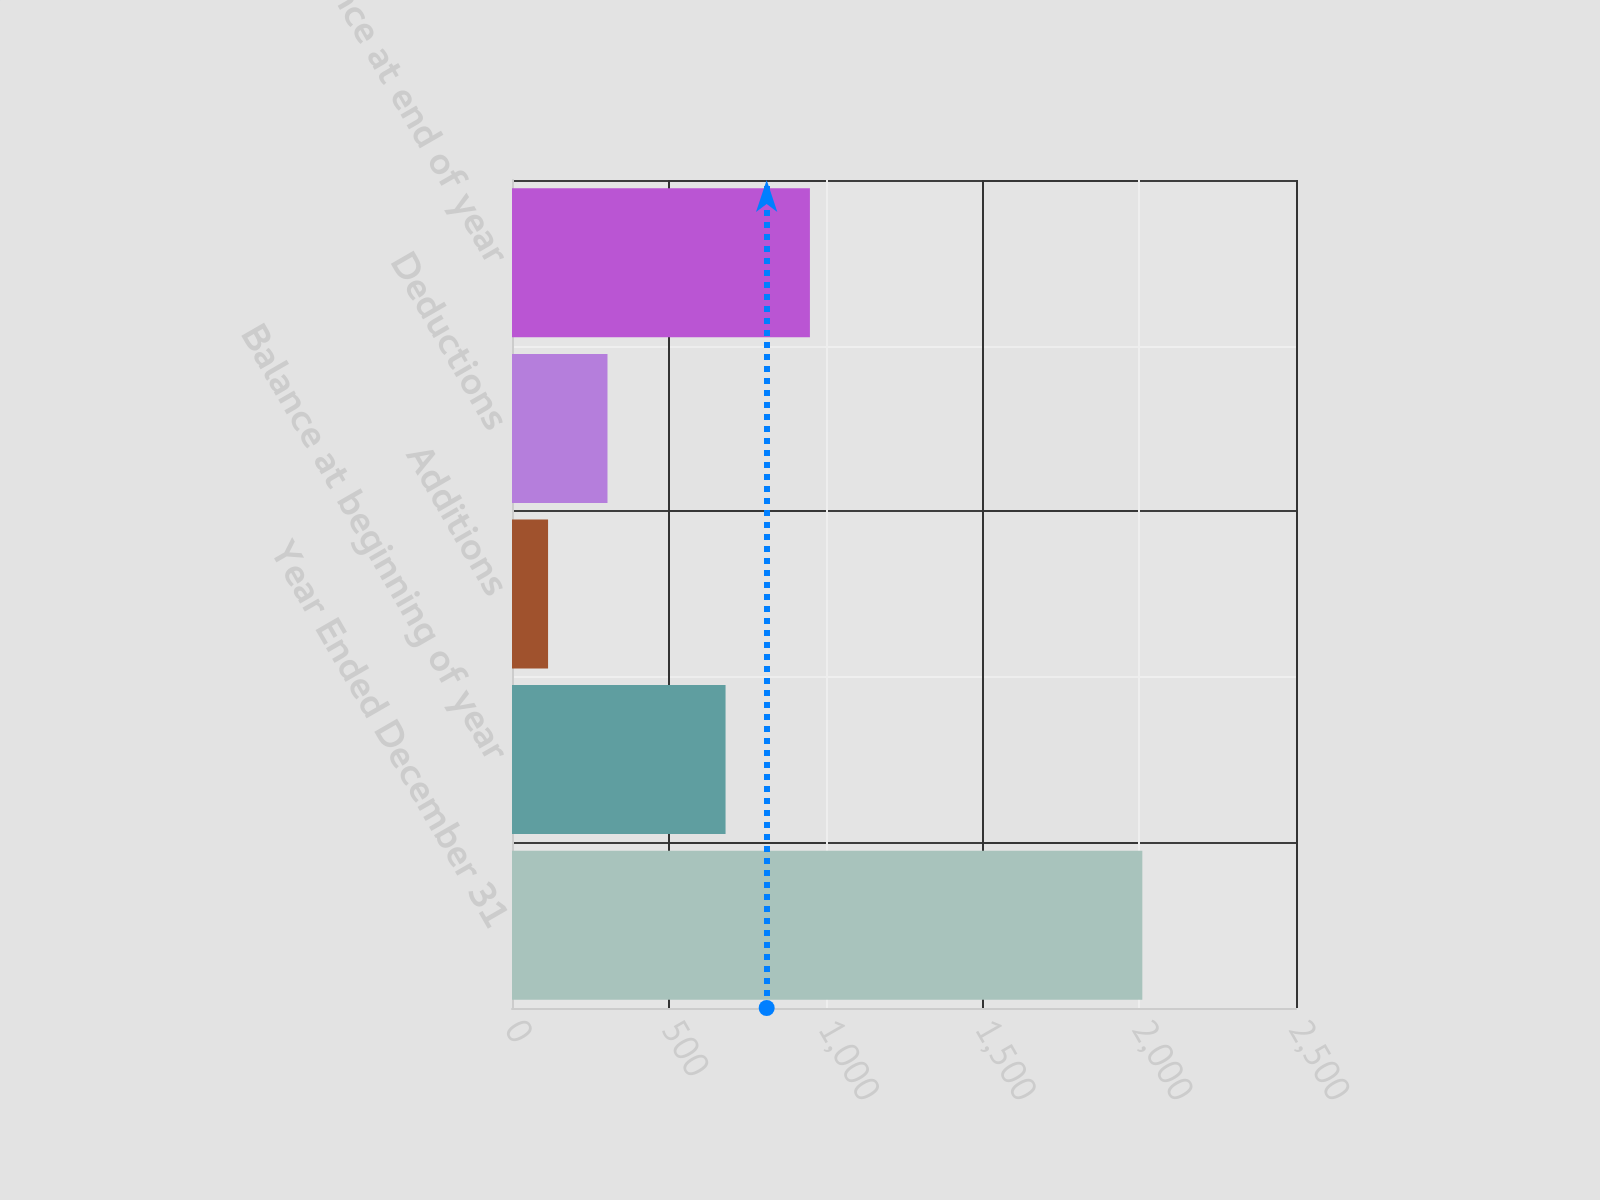<chart> <loc_0><loc_0><loc_500><loc_500><bar_chart><fcel>Year Ended December 31<fcel>Balance at beginning of year<fcel>Additions<fcel>Deductions<fcel>Balance at end of year<nl><fcel>2010<fcel>681<fcel>115<fcel>304.5<fcel>950<nl></chart> 